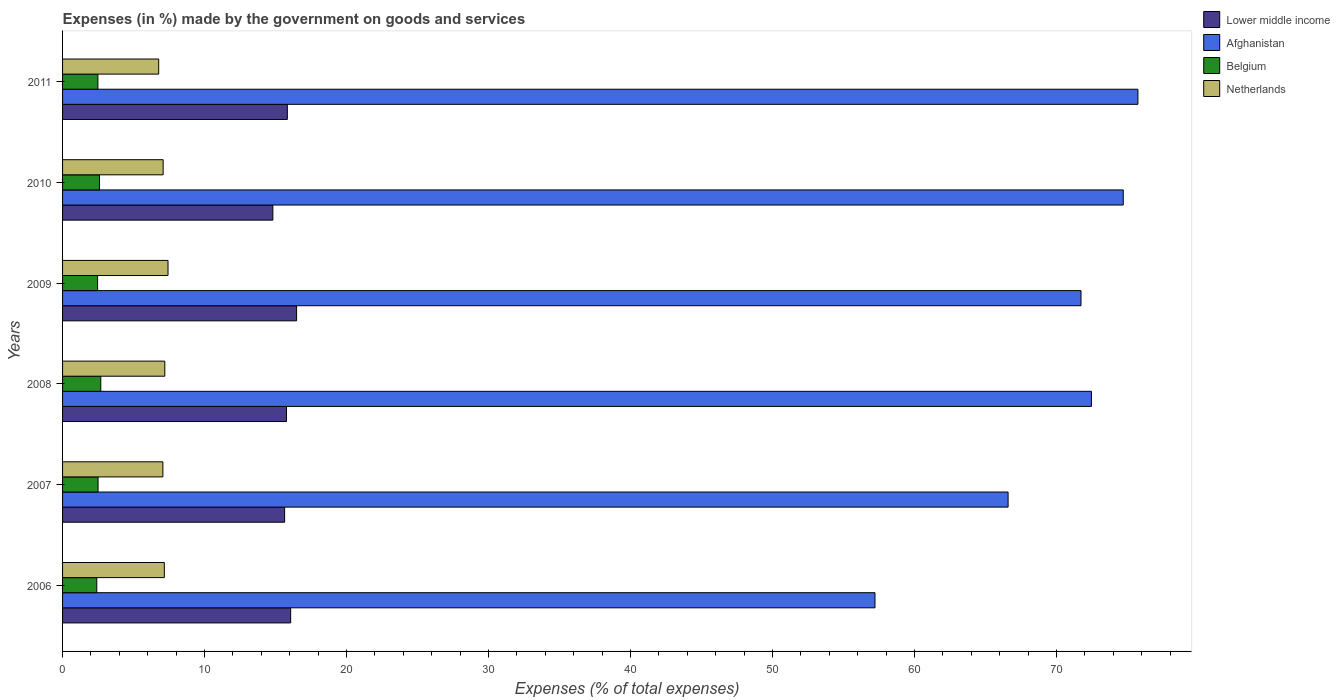Are the number of bars on each tick of the Y-axis equal?
Your answer should be compact. Yes. How many bars are there on the 3rd tick from the bottom?
Provide a short and direct response. 4. What is the label of the 5th group of bars from the top?
Ensure brevity in your answer.  2007. What is the percentage of expenses made by the government on goods and services in Belgium in 2008?
Your answer should be compact. 2.69. Across all years, what is the maximum percentage of expenses made by the government on goods and services in Netherlands?
Provide a short and direct response. 7.43. Across all years, what is the minimum percentage of expenses made by the government on goods and services in Belgium?
Provide a succinct answer. 2.41. In which year was the percentage of expenses made by the government on goods and services in Lower middle income maximum?
Offer a terse response. 2009. In which year was the percentage of expenses made by the government on goods and services in Lower middle income minimum?
Provide a succinct answer. 2010. What is the total percentage of expenses made by the government on goods and services in Netherlands in the graph?
Give a very brief answer. 42.71. What is the difference between the percentage of expenses made by the government on goods and services in Afghanistan in 2009 and that in 2010?
Keep it short and to the point. -2.98. What is the difference between the percentage of expenses made by the government on goods and services in Afghanistan in 2006 and the percentage of expenses made by the government on goods and services in Lower middle income in 2011?
Your answer should be compact. 41.39. What is the average percentage of expenses made by the government on goods and services in Lower middle income per year?
Offer a very short reply. 15.77. In the year 2007, what is the difference between the percentage of expenses made by the government on goods and services in Belgium and percentage of expenses made by the government on goods and services in Netherlands?
Offer a very short reply. -4.56. In how many years, is the percentage of expenses made by the government on goods and services in Afghanistan greater than 66 %?
Keep it short and to the point. 5. What is the ratio of the percentage of expenses made by the government on goods and services in Netherlands in 2008 to that in 2011?
Provide a short and direct response. 1.06. Is the percentage of expenses made by the government on goods and services in Netherlands in 2008 less than that in 2010?
Keep it short and to the point. No. Is the difference between the percentage of expenses made by the government on goods and services in Belgium in 2008 and 2009 greater than the difference between the percentage of expenses made by the government on goods and services in Netherlands in 2008 and 2009?
Make the answer very short. Yes. What is the difference between the highest and the second highest percentage of expenses made by the government on goods and services in Netherlands?
Provide a short and direct response. 0.23. What is the difference between the highest and the lowest percentage of expenses made by the government on goods and services in Netherlands?
Provide a succinct answer. 0.66. Is the sum of the percentage of expenses made by the government on goods and services in Afghanistan in 2008 and 2011 greater than the maximum percentage of expenses made by the government on goods and services in Netherlands across all years?
Offer a terse response. Yes. Is it the case that in every year, the sum of the percentage of expenses made by the government on goods and services in Lower middle income and percentage of expenses made by the government on goods and services in Afghanistan is greater than the sum of percentage of expenses made by the government on goods and services in Netherlands and percentage of expenses made by the government on goods and services in Belgium?
Give a very brief answer. Yes. Where does the legend appear in the graph?
Provide a short and direct response. Top right. How are the legend labels stacked?
Offer a very short reply. Vertical. What is the title of the graph?
Ensure brevity in your answer.  Expenses (in %) made by the government on goods and services. What is the label or title of the X-axis?
Keep it short and to the point. Expenses (% of total expenses). What is the Expenses (% of total expenses) of Lower middle income in 2006?
Make the answer very short. 16.07. What is the Expenses (% of total expenses) in Afghanistan in 2006?
Your response must be concise. 57.22. What is the Expenses (% of total expenses) of Belgium in 2006?
Your response must be concise. 2.41. What is the Expenses (% of total expenses) of Netherlands in 2006?
Ensure brevity in your answer.  7.17. What is the Expenses (% of total expenses) of Lower middle income in 2007?
Offer a terse response. 15.64. What is the Expenses (% of total expenses) of Afghanistan in 2007?
Your answer should be compact. 66.59. What is the Expenses (% of total expenses) of Belgium in 2007?
Ensure brevity in your answer.  2.5. What is the Expenses (% of total expenses) of Netherlands in 2007?
Give a very brief answer. 7.06. What is the Expenses (% of total expenses) in Lower middle income in 2008?
Keep it short and to the point. 15.77. What is the Expenses (% of total expenses) of Afghanistan in 2008?
Provide a short and direct response. 72.46. What is the Expenses (% of total expenses) in Belgium in 2008?
Give a very brief answer. 2.69. What is the Expenses (% of total expenses) in Netherlands in 2008?
Offer a very short reply. 7.2. What is the Expenses (% of total expenses) in Lower middle income in 2009?
Offer a terse response. 16.48. What is the Expenses (% of total expenses) of Afghanistan in 2009?
Provide a succinct answer. 71.72. What is the Expenses (% of total expenses) of Belgium in 2009?
Offer a terse response. 2.47. What is the Expenses (% of total expenses) in Netherlands in 2009?
Your answer should be very brief. 7.43. What is the Expenses (% of total expenses) of Lower middle income in 2010?
Make the answer very short. 14.81. What is the Expenses (% of total expenses) in Afghanistan in 2010?
Ensure brevity in your answer.  74.7. What is the Expenses (% of total expenses) of Belgium in 2010?
Make the answer very short. 2.6. What is the Expenses (% of total expenses) in Netherlands in 2010?
Your response must be concise. 7.08. What is the Expenses (% of total expenses) in Lower middle income in 2011?
Offer a terse response. 15.83. What is the Expenses (% of total expenses) in Afghanistan in 2011?
Your answer should be very brief. 75.73. What is the Expenses (% of total expenses) of Belgium in 2011?
Give a very brief answer. 2.49. What is the Expenses (% of total expenses) of Netherlands in 2011?
Offer a very short reply. 6.77. Across all years, what is the maximum Expenses (% of total expenses) in Lower middle income?
Offer a terse response. 16.48. Across all years, what is the maximum Expenses (% of total expenses) of Afghanistan?
Make the answer very short. 75.73. Across all years, what is the maximum Expenses (% of total expenses) of Belgium?
Keep it short and to the point. 2.69. Across all years, what is the maximum Expenses (% of total expenses) of Netherlands?
Offer a very short reply. 7.43. Across all years, what is the minimum Expenses (% of total expenses) of Lower middle income?
Provide a succinct answer. 14.81. Across all years, what is the minimum Expenses (% of total expenses) in Afghanistan?
Your response must be concise. 57.22. Across all years, what is the minimum Expenses (% of total expenses) in Belgium?
Give a very brief answer. 2.41. Across all years, what is the minimum Expenses (% of total expenses) in Netherlands?
Provide a short and direct response. 6.77. What is the total Expenses (% of total expenses) of Lower middle income in the graph?
Provide a succinct answer. 94.6. What is the total Expenses (% of total expenses) of Afghanistan in the graph?
Give a very brief answer. 418.42. What is the total Expenses (% of total expenses) in Belgium in the graph?
Your answer should be compact. 15.16. What is the total Expenses (% of total expenses) of Netherlands in the graph?
Provide a succinct answer. 42.71. What is the difference between the Expenses (% of total expenses) of Lower middle income in 2006 and that in 2007?
Make the answer very short. 0.43. What is the difference between the Expenses (% of total expenses) in Afghanistan in 2006 and that in 2007?
Your answer should be compact. -9.37. What is the difference between the Expenses (% of total expenses) in Belgium in 2006 and that in 2007?
Offer a terse response. -0.09. What is the difference between the Expenses (% of total expenses) of Netherlands in 2006 and that in 2007?
Keep it short and to the point. 0.1. What is the difference between the Expenses (% of total expenses) of Lower middle income in 2006 and that in 2008?
Ensure brevity in your answer.  0.29. What is the difference between the Expenses (% of total expenses) in Afghanistan in 2006 and that in 2008?
Ensure brevity in your answer.  -15.24. What is the difference between the Expenses (% of total expenses) in Belgium in 2006 and that in 2008?
Keep it short and to the point. -0.28. What is the difference between the Expenses (% of total expenses) in Netherlands in 2006 and that in 2008?
Offer a terse response. -0.03. What is the difference between the Expenses (% of total expenses) in Lower middle income in 2006 and that in 2009?
Your answer should be very brief. -0.42. What is the difference between the Expenses (% of total expenses) of Afghanistan in 2006 and that in 2009?
Provide a succinct answer. -14.51. What is the difference between the Expenses (% of total expenses) in Belgium in 2006 and that in 2009?
Ensure brevity in your answer.  -0.06. What is the difference between the Expenses (% of total expenses) in Netherlands in 2006 and that in 2009?
Offer a terse response. -0.26. What is the difference between the Expenses (% of total expenses) in Lower middle income in 2006 and that in 2010?
Provide a short and direct response. 1.25. What is the difference between the Expenses (% of total expenses) in Afghanistan in 2006 and that in 2010?
Provide a short and direct response. -17.48. What is the difference between the Expenses (% of total expenses) of Belgium in 2006 and that in 2010?
Provide a succinct answer. -0.19. What is the difference between the Expenses (% of total expenses) of Netherlands in 2006 and that in 2010?
Offer a very short reply. 0.08. What is the difference between the Expenses (% of total expenses) in Lower middle income in 2006 and that in 2011?
Offer a terse response. 0.23. What is the difference between the Expenses (% of total expenses) of Afghanistan in 2006 and that in 2011?
Your answer should be very brief. -18.52. What is the difference between the Expenses (% of total expenses) in Belgium in 2006 and that in 2011?
Ensure brevity in your answer.  -0.08. What is the difference between the Expenses (% of total expenses) in Netherlands in 2006 and that in 2011?
Keep it short and to the point. 0.4. What is the difference between the Expenses (% of total expenses) in Lower middle income in 2007 and that in 2008?
Provide a succinct answer. -0.13. What is the difference between the Expenses (% of total expenses) of Afghanistan in 2007 and that in 2008?
Ensure brevity in your answer.  -5.87. What is the difference between the Expenses (% of total expenses) of Belgium in 2007 and that in 2008?
Provide a succinct answer. -0.19. What is the difference between the Expenses (% of total expenses) of Netherlands in 2007 and that in 2008?
Your answer should be compact. -0.13. What is the difference between the Expenses (% of total expenses) of Lower middle income in 2007 and that in 2009?
Your response must be concise. -0.84. What is the difference between the Expenses (% of total expenses) in Afghanistan in 2007 and that in 2009?
Ensure brevity in your answer.  -5.13. What is the difference between the Expenses (% of total expenses) of Belgium in 2007 and that in 2009?
Your answer should be compact. 0.03. What is the difference between the Expenses (% of total expenses) of Netherlands in 2007 and that in 2009?
Your response must be concise. -0.36. What is the difference between the Expenses (% of total expenses) in Lower middle income in 2007 and that in 2010?
Offer a very short reply. 0.83. What is the difference between the Expenses (% of total expenses) in Afghanistan in 2007 and that in 2010?
Provide a succinct answer. -8.11. What is the difference between the Expenses (% of total expenses) in Belgium in 2007 and that in 2010?
Offer a very short reply. -0.1. What is the difference between the Expenses (% of total expenses) of Netherlands in 2007 and that in 2010?
Keep it short and to the point. -0.02. What is the difference between the Expenses (% of total expenses) in Lower middle income in 2007 and that in 2011?
Offer a terse response. -0.19. What is the difference between the Expenses (% of total expenses) of Afghanistan in 2007 and that in 2011?
Keep it short and to the point. -9.14. What is the difference between the Expenses (% of total expenses) of Belgium in 2007 and that in 2011?
Offer a very short reply. 0.01. What is the difference between the Expenses (% of total expenses) in Netherlands in 2007 and that in 2011?
Your answer should be compact. 0.29. What is the difference between the Expenses (% of total expenses) of Lower middle income in 2008 and that in 2009?
Offer a very short reply. -0.71. What is the difference between the Expenses (% of total expenses) in Afghanistan in 2008 and that in 2009?
Ensure brevity in your answer.  0.73. What is the difference between the Expenses (% of total expenses) in Belgium in 2008 and that in 2009?
Keep it short and to the point. 0.22. What is the difference between the Expenses (% of total expenses) of Netherlands in 2008 and that in 2009?
Provide a short and direct response. -0.23. What is the difference between the Expenses (% of total expenses) of Lower middle income in 2008 and that in 2010?
Give a very brief answer. 0.96. What is the difference between the Expenses (% of total expenses) of Afghanistan in 2008 and that in 2010?
Give a very brief answer. -2.24. What is the difference between the Expenses (% of total expenses) of Belgium in 2008 and that in 2010?
Provide a succinct answer. 0.09. What is the difference between the Expenses (% of total expenses) of Netherlands in 2008 and that in 2010?
Keep it short and to the point. 0.12. What is the difference between the Expenses (% of total expenses) of Lower middle income in 2008 and that in 2011?
Ensure brevity in your answer.  -0.06. What is the difference between the Expenses (% of total expenses) of Afghanistan in 2008 and that in 2011?
Offer a very short reply. -3.27. What is the difference between the Expenses (% of total expenses) of Belgium in 2008 and that in 2011?
Ensure brevity in your answer.  0.2. What is the difference between the Expenses (% of total expenses) of Netherlands in 2008 and that in 2011?
Ensure brevity in your answer.  0.43. What is the difference between the Expenses (% of total expenses) of Lower middle income in 2009 and that in 2010?
Provide a succinct answer. 1.67. What is the difference between the Expenses (% of total expenses) of Afghanistan in 2009 and that in 2010?
Offer a very short reply. -2.98. What is the difference between the Expenses (% of total expenses) of Belgium in 2009 and that in 2010?
Give a very brief answer. -0.14. What is the difference between the Expenses (% of total expenses) of Netherlands in 2009 and that in 2010?
Keep it short and to the point. 0.34. What is the difference between the Expenses (% of total expenses) of Lower middle income in 2009 and that in 2011?
Make the answer very short. 0.65. What is the difference between the Expenses (% of total expenses) in Afghanistan in 2009 and that in 2011?
Keep it short and to the point. -4.01. What is the difference between the Expenses (% of total expenses) of Belgium in 2009 and that in 2011?
Give a very brief answer. -0.02. What is the difference between the Expenses (% of total expenses) of Netherlands in 2009 and that in 2011?
Provide a short and direct response. 0.66. What is the difference between the Expenses (% of total expenses) in Lower middle income in 2010 and that in 2011?
Provide a short and direct response. -1.02. What is the difference between the Expenses (% of total expenses) in Afghanistan in 2010 and that in 2011?
Offer a very short reply. -1.03. What is the difference between the Expenses (% of total expenses) in Belgium in 2010 and that in 2011?
Your response must be concise. 0.11. What is the difference between the Expenses (% of total expenses) of Netherlands in 2010 and that in 2011?
Your answer should be compact. 0.31. What is the difference between the Expenses (% of total expenses) of Lower middle income in 2006 and the Expenses (% of total expenses) of Afghanistan in 2007?
Make the answer very short. -50.52. What is the difference between the Expenses (% of total expenses) in Lower middle income in 2006 and the Expenses (% of total expenses) in Belgium in 2007?
Provide a short and direct response. 13.57. What is the difference between the Expenses (% of total expenses) of Lower middle income in 2006 and the Expenses (% of total expenses) of Netherlands in 2007?
Offer a very short reply. 9. What is the difference between the Expenses (% of total expenses) in Afghanistan in 2006 and the Expenses (% of total expenses) in Belgium in 2007?
Your answer should be very brief. 54.72. What is the difference between the Expenses (% of total expenses) of Afghanistan in 2006 and the Expenses (% of total expenses) of Netherlands in 2007?
Your response must be concise. 50.15. What is the difference between the Expenses (% of total expenses) of Belgium in 2006 and the Expenses (% of total expenses) of Netherlands in 2007?
Your response must be concise. -4.66. What is the difference between the Expenses (% of total expenses) in Lower middle income in 2006 and the Expenses (% of total expenses) in Afghanistan in 2008?
Make the answer very short. -56.39. What is the difference between the Expenses (% of total expenses) of Lower middle income in 2006 and the Expenses (% of total expenses) of Belgium in 2008?
Ensure brevity in your answer.  13.38. What is the difference between the Expenses (% of total expenses) of Lower middle income in 2006 and the Expenses (% of total expenses) of Netherlands in 2008?
Offer a terse response. 8.87. What is the difference between the Expenses (% of total expenses) in Afghanistan in 2006 and the Expenses (% of total expenses) in Belgium in 2008?
Your answer should be very brief. 54.53. What is the difference between the Expenses (% of total expenses) in Afghanistan in 2006 and the Expenses (% of total expenses) in Netherlands in 2008?
Provide a succinct answer. 50.02. What is the difference between the Expenses (% of total expenses) in Belgium in 2006 and the Expenses (% of total expenses) in Netherlands in 2008?
Ensure brevity in your answer.  -4.79. What is the difference between the Expenses (% of total expenses) in Lower middle income in 2006 and the Expenses (% of total expenses) in Afghanistan in 2009?
Offer a very short reply. -55.66. What is the difference between the Expenses (% of total expenses) in Lower middle income in 2006 and the Expenses (% of total expenses) in Belgium in 2009?
Your answer should be very brief. 13.6. What is the difference between the Expenses (% of total expenses) in Lower middle income in 2006 and the Expenses (% of total expenses) in Netherlands in 2009?
Your answer should be compact. 8.64. What is the difference between the Expenses (% of total expenses) of Afghanistan in 2006 and the Expenses (% of total expenses) of Belgium in 2009?
Offer a terse response. 54.75. What is the difference between the Expenses (% of total expenses) of Afghanistan in 2006 and the Expenses (% of total expenses) of Netherlands in 2009?
Ensure brevity in your answer.  49.79. What is the difference between the Expenses (% of total expenses) of Belgium in 2006 and the Expenses (% of total expenses) of Netherlands in 2009?
Ensure brevity in your answer.  -5.02. What is the difference between the Expenses (% of total expenses) of Lower middle income in 2006 and the Expenses (% of total expenses) of Afghanistan in 2010?
Ensure brevity in your answer.  -58.63. What is the difference between the Expenses (% of total expenses) in Lower middle income in 2006 and the Expenses (% of total expenses) in Belgium in 2010?
Your answer should be very brief. 13.46. What is the difference between the Expenses (% of total expenses) of Lower middle income in 2006 and the Expenses (% of total expenses) of Netherlands in 2010?
Keep it short and to the point. 8.98. What is the difference between the Expenses (% of total expenses) in Afghanistan in 2006 and the Expenses (% of total expenses) in Belgium in 2010?
Provide a succinct answer. 54.61. What is the difference between the Expenses (% of total expenses) of Afghanistan in 2006 and the Expenses (% of total expenses) of Netherlands in 2010?
Provide a succinct answer. 50.13. What is the difference between the Expenses (% of total expenses) in Belgium in 2006 and the Expenses (% of total expenses) in Netherlands in 2010?
Your answer should be very brief. -4.67. What is the difference between the Expenses (% of total expenses) in Lower middle income in 2006 and the Expenses (% of total expenses) in Afghanistan in 2011?
Keep it short and to the point. -59.67. What is the difference between the Expenses (% of total expenses) in Lower middle income in 2006 and the Expenses (% of total expenses) in Belgium in 2011?
Your response must be concise. 13.58. What is the difference between the Expenses (% of total expenses) in Lower middle income in 2006 and the Expenses (% of total expenses) in Netherlands in 2011?
Give a very brief answer. 9.3. What is the difference between the Expenses (% of total expenses) of Afghanistan in 2006 and the Expenses (% of total expenses) of Belgium in 2011?
Ensure brevity in your answer.  54.73. What is the difference between the Expenses (% of total expenses) in Afghanistan in 2006 and the Expenses (% of total expenses) in Netherlands in 2011?
Your answer should be very brief. 50.45. What is the difference between the Expenses (% of total expenses) of Belgium in 2006 and the Expenses (% of total expenses) of Netherlands in 2011?
Ensure brevity in your answer.  -4.36. What is the difference between the Expenses (% of total expenses) of Lower middle income in 2007 and the Expenses (% of total expenses) of Afghanistan in 2008?
Offer a very short reply. -56.82. What is the difference between the Expenses (% of total expenses) of Lower middle income in 2007 and the Expenses (% of total expenses) of Belgium in 2008?
Ensure brevity in your answer.  12.95. What is the difference between the Expenses (% of total expenses) in Lower middle income in 2007 and the Expenses (% of total expenses) in Netherlands in 2008?
Offer a very short reply. 8.44. What is the difference between the Expenses (% of total expenses) of Afghanistan in 2007 and the Expenses (% of total expenses) of Belgium in 2008?
Your answer should be very brief. 63.9. What is the difference between the Expenses (% of total expenses) of Afghanistan in 2007 and the Expenses (% of total expenses) of Netherlands in 2008?
Offer a terse response. 59.39. What is the difference between the Expenses (% of total expenses) in Belgium in 2007 and the Expenses (% of total expenses) in Netherlands in 2008?
Provide a succinct answer. -4.7. What is the difference between the Expenses (% of total expenses) of Lower middle income in 2007 and the Expenses (% of total expenses) of Afghanistan in 2009?
Ensure brevity in your answer.  -56.09. What is the difference between the Expenses (% of total expenses) in Lower middle income in 2007 and the Expenses (% of total expenses) in Belgium in 2009?
Give a very brief answer. 13.17. What is the difference between the Expenses (% of total expenses) of Lower middle income in 2007 and the Expenses (% of total expenses) of Netherlands in 2009?
Provide a succinct answer. 8.21. What is the difference between the Expenses (% of total expenses) of Afghanistan in 2007 and the Expenses (% of total expenses) of Belgium in 2009?
Give a very brief answer. 64.12. What is the difference between the Expenses (% of total expenses) of Afghanistan in 2007 and the Expenses (% of total expenses) of Netherlands in 2009?
Keep it short and to the point. 59.16. What is the difference between the Expenses (% of total expenses) in Belgium in 2007 and the Expenses (% of total expenses) in Netherlands in 2009?
Give a very brief answer. -4.93. What is the difference between the Expenses (% of total expenses) in Lower middle income in 2007 and the Expenses (% of total expenses) in Afghanistan in 2010?
Make the answer very short. -59.06. What is the difference between the Expenses (% of total expenses) of Lower middle income in 2007 and the Expenses (% of total expenses) of Belgium in 2010?
Ensure brevity in your answer.  13.04. What is the difference between the Expenses (% of total expenses) of Lower middle income in 2007 and the Expenses (% of total expenses) of Netherlands in 2010?
Offer a very short reply. 8.56. What is the difference between the Expenses (% of total expenses) of Afghanistan in 2007 and the Expenses (% of total expenses) of Belgium in 2010?
Ensure brevity in your answer.  63.99. What is the difference between the Expenses (% of total expenses) of Afghanistan in 2007 and the Expenses (% of total expenses) of Netherlands in 2010?
Give a very brief answer. 59.51. What is the difference between the Expenses (% of total expenses) in Belgium in 2007 and the Expenses (% of total expenses) in Netherlands in 2010?
Your answer should be compact. -4.58. What is the difference between the Expenses (% of total expenses) in Lower middle income in 2007 and the Expenses (% of total expenses) in Afghanistan in 2011?
Ensure brevity in your answer.  -60.09. What is the difference between the Expenses (% of total expenses) of Lower middle income in 2007 and the Expenses (% of total expenses) of Belgium in 2011?
Your response must be concise. 13.15. What is the difference between the Expenses (% of total expenses) of Lower middle income in 2007 and the Expenses (% of total expenses) of Netherlands in 2011?
Offer a terse response. 8.87. What is the difference between the Expenses (% of total expenses) of Afghanistan in 2007 and the Expenses (% of total expenses) of Belgium in 2011?
Ensure brevity in your answer.  64.1. What is the difference between the Expenses (% of total expenses) of Afghanistan in 2007 and the Expenses (% of total expenses) of Netherlands in 2011?
Your answer should be compact. 59.82. What is the difference between the Expenses (% of total expenses) in Belgium in 2007 and the Expenses (% of total expenses) in Netherlands in 2011?
Offer a terse response. -4.27. What is the difference between the Expenses (% of total expenses) of Lower middle income in 2008 and the Expenses (% of total expenses) of Afghanistan in 2009?
Offer a very short reply. -55.95. What is the difference between the Expenses (% of total expenses) in Lower middle income in 2008 and the Expenses (% of total expenses) in Belgium in 2009?
Your answer should be compact. 13.3. What is the difference between the Expenses (% of total expenses) of Lower middle income in 2008 and the Expenses (% of total expenses) of Netherlands in 2009?
Your answer should be very brief. 8.34. What is the difference between the Expenses (% of total expenses) in Afghanistan in 2008 and the Expenses (% of total expenses) in Belgium in 2009?
Your answer should be compact. 69.99. What is the difference between the Expenses (% of total expenses) in Afghanistan in 2008 and the Expenses (% of total expenses) in Netherlands in 2009?
Your answer should be compact. 65.03. What is the difference between the Expenses (% of total expenses) in Belgium in 2008 and the Expenses (% of total expenses) in Netherlands in 2009?
Your answer should be compact. -4.74. What is the difference between the Expenses (% of total expenses) of Lower middle income in 2008 and the Expenses (% of total expenses) of Afghanistan in 2010?
Your answer should be very brief. -58.93. What is the difference between the Expenses (% of total expenses) of Lower middle income in 2008 and the Expenses (% of total expenses) of Belgium in 2010?
Provide a succinct answer. 13.17. What is the difference between the Expenses (% of total expenses) of Lower middle income in 2008 and the Expenses (% of total expenses) of Netherlands in 2010?
Give a very brief answer. 8.69. What is the difference between the Expenses (% of total expenses) in Afghanistan in 2008 and the Expenses (% of total expenses) in Belgium in 2010?
Provide a succinct answer. 69.86. What is the difference between the Expenses (% of total expenses) of Afghanistan in 2008 and the Expenses (% of total expenses) of Netherlands in 2010?
Your answer should be very brief. 65.38. What is the difference between the Expenses (% of total expenses) in Belgium in 2008 and the Expenses (% of total expenses) in Netherlands in 2010?
Provide a short and direct response. -4.39. What is the difference between the Expenses (% of total expenses) in Lower middle income in 2008 and the Expenses (% of total expenses) in Afghanistan in 2011?
Provide a succinct answer. -59.96. What is the difference between the Expenses (% of total expenses) in Lower middle income in 2008 and the Expenses (% of total expenses) in Belgium in 2011?
Provide a succinct answer. 13.28. What is the difference between the Expenses (% of total expenses) of Lower middle income in 2008 and the Expenses (% of total expenses) of Netherlands in 2011?
Your response must be concise. 9. What is the difference between the Expenses (% of total expenses) in Afghanistan in 2008 and the Expenses (% of total expenses) in Belgium in 2011?
Give a very brief answer. 69.97. What is the difference between the Expenses (% of total expenses) of Afghanistan in 2008 and the Expenses (% of total expenses) of Netherlands in 2011?
Your answer should be compact. 65.69. What is the difference between the Expenses (% of total expenses) in Belgium in 2008 and the Expenses (% of total expenses) in Netherlands in 2011?
Provide a succinct answer. -4.08. What is the difference between the Expenses (% of total expenses) of Lower middle income in 2009 and the Expenses (% of total expenses) of Afghanistan in 2010?
Your answer should be very brief. -58.22. What is the difference between the Expenses (% of total expenses) in Lower middle income in 2009 and the Expenses (% of total expenses) in Belgium in 2010?
Make the answer very short. 13.88. What is the difference between the Expenses (% of total expenses) of Lower middle income in 2009 and the Expenses (% of total expenses) of Netherlands in 2010?
Ensure brevity in your answer.  9.4. What is the difference between the Expenses (% of total expenses) in Afghanistan in 2009 and the Expenses (% of total expenses) in Belgium in 2010?
Provide a succinct answer. 69.12. What is the difference between the Expenses (% of total expenses) of Afghanistan in 2009 and the Expenses (% of total expenses) of Netherlands in 2010?
Offer a terse response. 64.64. What is the difference between the Expenses (% of total expenses) in Belgium in 2009 and the Expenses (% of total expenses) in Netherlands in 2010?
Make the answer very short. -4.62. What is the difference between the Expenses (% of total expenses) of Lower middle income in 2009 and the Expenses (% of total expenses) of Afghanistan in 2011?
Your response must be concise. -59.25. What is the difference between the Expenses (% of total expenses) in Lower middle income in 2009 and the Expenses (% of total expenses) in Belgium in 2011?
Your answer should be very brief. 13.99. What is the difference between the Expenses (% of total expenses) of Lower middle income in 2009 and the Expenses (% of total expenses) of Netherlands in 2011?
Your answer should be very brief. 9.71. What is the difference between the Expenses (% of total expenses) in Afghanistan in 2009 and the Expenses (% of total expenses) in Belgium in 2011?
Your answer should be compact. 69.23. What is the difference between the Expenses (% of total expenses) in Afghanistan in 2009 and the Expenses (% of total expenses) in Netherlands in 2011?
Your response must be concise. 64.95. What is the difference between the Expenses (% of total expenses) in Belgium in 2009 and the Expenses (% of total expenses) in Netherlands in 2011?
Offer a very short reply. -4.3. What is the difference between the Expenses (% of total expenses) of Lower middle income in 2010 and the Expenses (% of total expenses) of Afghanistan in 2011?
Provide a succinct answer. -60.92. What is the difference between the Expenses (% of total expenses) in Lower middle income in 2010 and the Expenses (% of total expenses) in Belgium in 2011?
Give a very brief answer. 12.32. What is the difference between the Expenses (% of total expenses) of Lower middle income in 2010 and the Expenses (% of total expenses) of Netherlands in 2011?
Keep it short and to the point. 8.04. What is the difference between the Expenses (% of total expenses) of Afghanistan in 2010 and the Expenses (% of total expenses) of Belgium in 2011?
Your response must be concise. 72.21. What is the difference between the Expenses (% of total expenses) in Afghanistan in 2010 and the Expenses (% of total expenses) in Netherlands in 2011?
Offer a very short reply. 67.93. What is the difference between the Expenses (% of total expenses) of Belgium in 2010 and the Expenses (% of total expenses) of Netherlands in 2011?
Your answer should be compact. -4.17. What is the average Expenses (% of total expenses) of Lower middle income per year?
Your answer should be compact. 15.77. What is the average Expenses (% of total expenses) of Afghanistan per year?
Your answer should be very brief. 69.74. What is the average Expenses (% of total expenses) of Belgium per year?
Keep it short and to the point. 2.53. What is the average Expenses (% of total expenses) in Netherlands per year?
Make the answer very short. 7.12. In the year 2006, what is the difference between the Expenses (% of total expenses) in Lower middle income and Expenses (% of total expenses) in Afghanistan?
Your answer should be very brief. -41.15. In the year 2006, what is the difference between the Expenses (% of total expenses) of Lower middle income and Expenses (% of total expenses) of Belgium?
Your response must be concise. 13.66. In the year 2006, what is the difference between the Expenses (% of total expenses) of Lower middle income and Expenses (% of total expenses) of Netherlands?
Your answer should be compact. 8.9. In the year 2006, what is the difference between the Expenses (% of total expenses) in Afghanistan and Expenses (% of total expenses) in Belgium?
Your response must be concise. 54.81. In the year 2006, what is the difference between the Expenses (% of total expenses) of Afghanistan and Expenses (% of total expenses) of Netherlands?
Provide a succinct answer. 50.05. In the year 2006, what is the difference between the Expenses (% of total expenses) in Belgium and Expenses (% of total expenses) in Netherlands?
Your answer should be very brief. -4.76. In the year 2007, what is the difference between the Expenses (% of total expenses) in Lower middle income and Expenses (% of total expenses) in Afghanistan?
Your answer should be compact. -50.95. In the year 2007, what is the difference between the Expenses (% of total expenses) in Lower middle income and Expenses (% of total expenses) in Belgium?
Provide a succinct answer. 13.14. In the year 2007, what is the difference between the Expenses (% of total expenses) in Lower middle income and Expenses (% of total expenses) in Netherlands?
Offer a terse response. 8.57. In the year 2007, what is the difference between the Expenses (% of total expenses) of Afghanistan and Expenses (% of total expenses) of Belgium?
Make the answer very short. 64.09. In the year 2007, what is the difference between the Expenses (% of total expenses) in Afghanistan and Expenses (% of total expenses) in Netherlands?
Make the answer very short. 59.53. In the year 2007, what is the difference between the Expenses (% of total expenses) of Belgium and Expenses (% of total expenses) of Netherlands?
Your answer should be very brief. -4.56. In the year 2008, what is the difference between the Expenses (% of total expenses) in Lower middle income and Expenses (% of total expenses) in Afghanistan?
Your answer should be compact. -56.69. In the year 2008, what is the difference between the Expenses (% of total expenses) of Lower middle income and Expenses (% of total expenses) of Belgium?
Your answer should be very brief. 13.08. In the year 2008, what is the difference between the Expenses (% of total expenses) of Lower middle income and Expenses (% of total expenses) of Netherlands?
Offer a terse response. 8.57. In the year 2008, what is the difference between the Expenses (% of total expenses) in Afghanistan and Expenses (% of total expenses) in Belgium?
Ensure brevity in your answer.  69.77. In the year 2008, what is the difference between the Expenses (% of total expenses) of Afghanistan and Expenses (% of total expenses) of Netherlands?
Offer a terse response. 65.26. In the year 2008, what is the difference between the Expenses (% of total expenses) of Belgium and Expenses (% of total expenses) of Netherlands?
Provide a short and direct response. -4.51. In the year 2009, what is the difference between the Expenses (% of total expenses) in Lower middle income and Expenses (% of total expenses) in Afghanistan?
Your answer should be compact. -55.24. In the year 2009, what is the difference between the Expenses (% of total expenses) of Lower middle income and Expenses (% of total expenses) of Belgium?
Ensure brevity in your answer.  14.02. In the year 2009, what is the difference between the Expenses (% of total expenses) in Lower middle income and Expenses (% of total expenses) in Netherlands?
Your answer should be compact. 9.06. In the year 2009, what is the difference between the Expenses (% of total expenses) of Afghanistan and Expenses (% of total expenses) of Belgium?
Keep it short and to the point. 69.26. In the year 2009, what is the difference between the Expenses (% of total expenses) of Afghanistan and Expenses (% of total expenses) of Netherlands?
Ensure brevity in your answer.  64.3. In the year 2009, what is the difference between the Expenses (% of total expenses) in Belgium and Expenses (% of total expenses) in Netherlands?
Your answer should be compact. -4.96. In the year 2010, what is the difference between the Expenses (% of total expenses) of Lower middle income and Expenses (% of total expenses) of Afghanistan?
Provide a short and direct response. -59.89. In the year 2010, what is the difference between the Expenses (% of total expenses) of Lower middle income and Expenses (% of total expenses) of Belgium?
Offer a terse response. 12.21. In the year 2010, what is the difference between the Expenses (% of total expenses) of Lower middle income and Expenses (% of total expenses) of Netherlands?
Provide a succinct answer. 7.73. In the year 2010, what is the difference between the Expenses (% of total expenses) of Afghanistan and Expenses (% of total expenses) of Belgium?
Offer a terse response. 72.1. In the year 2010, what is the difference between the Expenses (% of total expenses) in Afghanistan and Expenses (% of total expenses) in Netherlands?
Give a very brief answer. 67.62. In the year 2010, what is the difference between the Expenses (% of total expenses) of Belgium and Expenses (% of total expenses) of Netherlands?
Provide a succinct answer. -4.48. In the year 2011, what is the difference between the Expenses (% of total expenses) in Lower middle income and Expenses (% of total expenses) in Afghanistan?
Make the answer very short. -59.9. In the year 2011, what is the difference between the Expenses (% of total expenses) of Lower middle income and Expenses (% of total expenses) of Belgium?
Offer a very short reply. 13.34. In the year 2011, what is the difference between the Expenses (% of total expenses) of Lower middle income and Expenses (% of total expenses) of Netherlands?
Offer a terse response. 9.06. In the year 2011, what is the difference between the Expenses (% of total expenses) of Afghanistan and Expenses (% of total expenses) of Belgium?
Provide a short and direct response. 73.24. In the year 2011, what is the difference between the Expenses (% of total expenses) in Afghanistan and Expenses (% of total expenses) in Netherlands?
Your response must be concise. 68.96. In the year 2011, what is the difference between the Expenses (% of total expenses) in Belgium and Expenses (% of total expenses) in Netherlands?
Offer a terse response. -4.28. What is the ratio of the Expenses (% of total expenses) in Lower middle income in 2006 to that in 2007?
Your answer should be compact. 1.03. What is the ratio of the Expenses (% of total expenses) in Afghanistan in 2006 to that in 2007?
Keep it short and to the point. 0.86. What is the ratio of the Expenses (% of total expenses) of Belgium in 2006 to that in 2007?
Give a very brief answer. 0.96. What is the ratio of the Expenses (% of total expenses) of Netherlands in 2006 to that in 2007?
Give a very brief answer. 1.01. What is the ratio of the Expenses (% of total expenses) in Lower middle income in 2006 to that in 2008?
Your answer should be compact. 1.02. What is the ratio of the Expenses (% of total expenses) in Afghanistan in 2006 to that in 2008?
Your answer should be compact. 0.79. What is the ratio of the Expenses (% of total expenses) of Belgium in 2006 to that in 2008?
Give a very brief answer. 0.9. What is the ratio of the Expenses (% of total expenses) of Lower middle income in 2006 to that in 2009?
Make the answer very short. 0.97. What is the ratio of the Expenses (% of total expenses) of Afghanistan in 2006 to that in 2009?
Your answer should be very brief. 0.8. What is the ratio of the Expenses (% of total expenses) in Belgium in 2006 to that in 2009?
Make the answer very short. 0.98. What is the ratio of the Expenses (% of total expenses) of Lower middle income in 2006 to that in 2010?
Offer a terse response. 1.08. What is the ratio of the Expenses (% of total expenses) in Afghanistan in 2006 to that in 2010?
Provide a short and direct response. 0.77. What is the ratio of the Expenses (% of total expenses) of Belgium in 2006 to that in 2010?
Your answer should be very brief. 0.93. What is the ratio of the Expenses (% of total expenses) in Netherlands in 2006 to that in 2010?
Ensure brevity in your answer.  1.01. What is the ratio of the Expenses (% of total expenses) in Lower middle income in 2006 to that in 2011?
Your answer should be compact. 1.01. What is the ratio of the Expenses (% of total expenses) of Afghanistan in 2006 to that in 2011?
Your answer should be very brief. 0.76. What is the ratio of the Expenses (% of total expenses) in Belgium in 2006 to that in 2011?
Ensure brevity in your answer.  0.97. What is the ratio of the Expenses (% of total expenses) in Netherlands in 2006 to that in 2011?
Offer a very short reply. 1.06. What is the ratio of the Expenses (% of total expenses) in Afghanistan in 2007 to that in 2008?
Ensure brevity in your answer.  0.92. What is the ratio of the Expenses (% of total expenses) of Belgium in 2007 to that in 2008?
Keep it short and to the point. 0.93. What is the ratio of the Expenses (% of total expenses) in Netherlands in 2007 to that in 2008?
Keep it short and to the point. 0.98. What is the ratio of the Expenses (% of total expenses) of Lower middle income in 2007 to that in 2009?
Your answer should be compact. 0.95. What is the ratio of the Expenses (% of total expenses) of Afghanistan in 2007 to that in 2009?
Your answer should be compact. 0.93. What is the ratio of the Expenses (% of total expenses) of Belgium in 2007 to that in 2009?
Ensure brevity in your answer.  1.01. What is the ratio of the Expenses (% of total expenses) of Netherlands in 2007 to that in 2009?
Offer a terse response. 0.95. What is the ratio of the Expenses (% of total expenses) of Lower middle income in 2007 to that in 2010?
Your answer should be very brief. 1.06. What is the ratio of the Expenses (% of total expenses) in Afghanistan in 2007 to that in 2010?
Offer a terse response. 0.89. What is the ratio of the Expenses (% of total expenses) in Belgium in 2007 to that in 2010?
Give a very brief answer. 0.96. What is the ratio of the Expenses (% of total expenses) in Lower middle income in 2007 to that in 2011?
Offer a terse response. 0.99. What is the ratio of the Expenses (% of total expenses) in Afghanistan in 2007 to that in 2011?
Offer a terse response. 0.88. What is the ratio of the Expenses (% of total expenses) in Netherlands in 2007 to that in 2011?
Offer a very short reply. 1.04. What is the ratio of the Expenses (% of total expenses) of Lower middle income in 2008 to that in 2009?
Your answer should be compact. 0.96. What is the ratio of the Expenses (% of total expenses) in Afghanistan in 2008 to that in 2009?
Provide a short and direct response. 1.01. What is the ratio of the Expenses (% of total expenses) of Belgium in 2008 to that in 2009?
Provide a short and direct response. 1.09. What is the ratio of the Expenses (% of total expenses) in Netherlands in 2008 to that in 2009?
Provide a short and direct response. 0.97. What is the ratio of the Expenses (% of total expenses) in Lower middle income in 2008 to that in 2010?
Your answer should be compact. 1.06. What is the ratio of the Expenses (% of total expenses) in Afghanistan in 2008 to that in 2010?
Your answer should be compact. 0.97. What is the ratio of the Expenses (% of total expenses) in Netherlands in 2008 to that in 2010?
Your answer should be very brief. 1.02. What is the ratio of the Expenses (% of total expenses) in Afghanistan in 2008 to that in 2011?
Keep it short and to the point. 0.96. What is the ratio of the Expenses (% of total expenses) in Belgium in 2008 to that in 2011?
Your answer should be very brief. 1.08. What is the ratio of the Expenses (% of total expenses) in Netherlands in 2008 to that in 2011?
Keep it short and to the point. 1.06. What is the ratio of the Expenses (% of total expenses) in Lower middle income in 2009 to that in 2010?
Give a very brief answer. 1.11. What is the ratio of the Expenses (% of total expenses) of Afghanistan in 2009 to that in 2010?
Your response must be concise. 0.96. What is the ratio of the Expenses (% of total expenses) in Belgium in 2009 to that in 2010?
Offer a very short reply. 0.95. What is the ratio of the Expenses (% of total expenses) of Netherlands in 2009 to that in 2010?
Your response must be concise. 1.05. What is the ratio of the Expenses (% of total expenses) in Lower middle income in 2009 to that in 2011?
Offer a terse response. 1.04. What is the ratio of the Expenses (% of total expenses) of Afghanistan in 2009 to that in 2011?
Give a very brief answer. 0.95. What is the ratio of the Expenses (% of total expenses) of Netherlands in 2009 to that in 2011?
Keep it short and to the point. 1.1. What is the ratio of the Expenses (% of total expenses) of Lower middle income in 2010 to that in 2011?
Offer a terse response. 0.94. What is the ratio of the Expenses (% of total expenses) of Afghanistan in 2010 to that in 2011?
Offer a terse response. 0.99. What is the ratio of the Expenses (% of total expenses) of Belgium in 2010 to that in 2011?
Offer a terse response. 1.05. What is the ratio of the Expenses (% of total expenses) of Netherlands in 2010 to that in 2011?
Your response must be concise. 1.05. What is the difference between the highest and the second highest Expenses (% of total expenses) in Lower middle income?
Make the answer very short. 0.42. What is the difference between the highest and the second highest Expenses (% of total expenses) of Afghanistan?
Offer a terse response. 1.03. What is the difference between the highest and the second highest Expenses (% of total expenses) in Belgium?
Your answer should be compact. 0.09. What is the difference between the highest and the second highest Expenses (% of total expenses) of Netherlands?
Keep it short and to the point. 0.23. What is the difference between the highest and the lowest Expenses (% of total expenses) of Lower middle income?
Ensure brevity in your answer.  1.67. What is the difference between the highest and the lowest Expenses (% of total expenses) of Afghanistan?
Your response must be concise. 18.52. What is the difference between the highest and the lowest Expenses (% of total expenses) of Belgium?
Offer a terse response. 0.28. What is the difference between the highest and the lowest Expenses (% of total expenses) of Netherlands?
Your response must be concise. 0.66. 